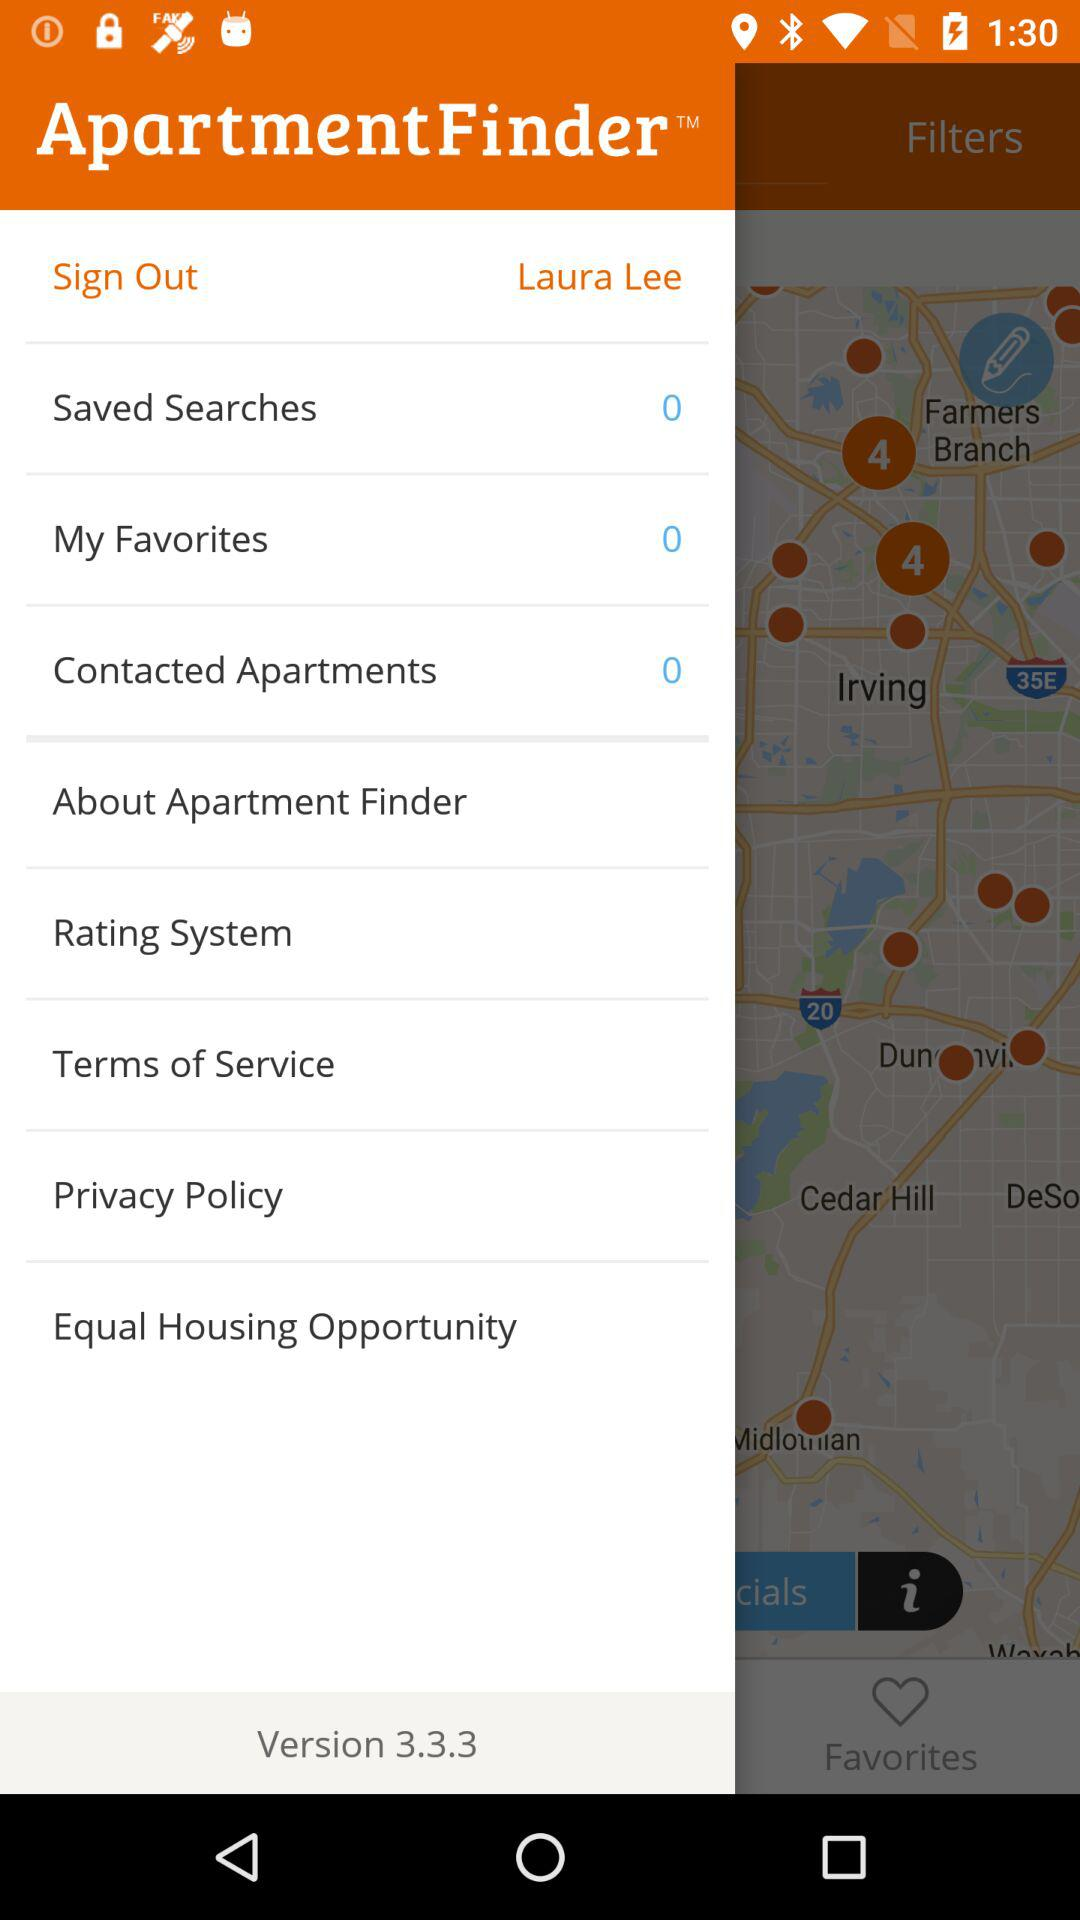What is the name of the user? The name of the user is "Laura Lee". 